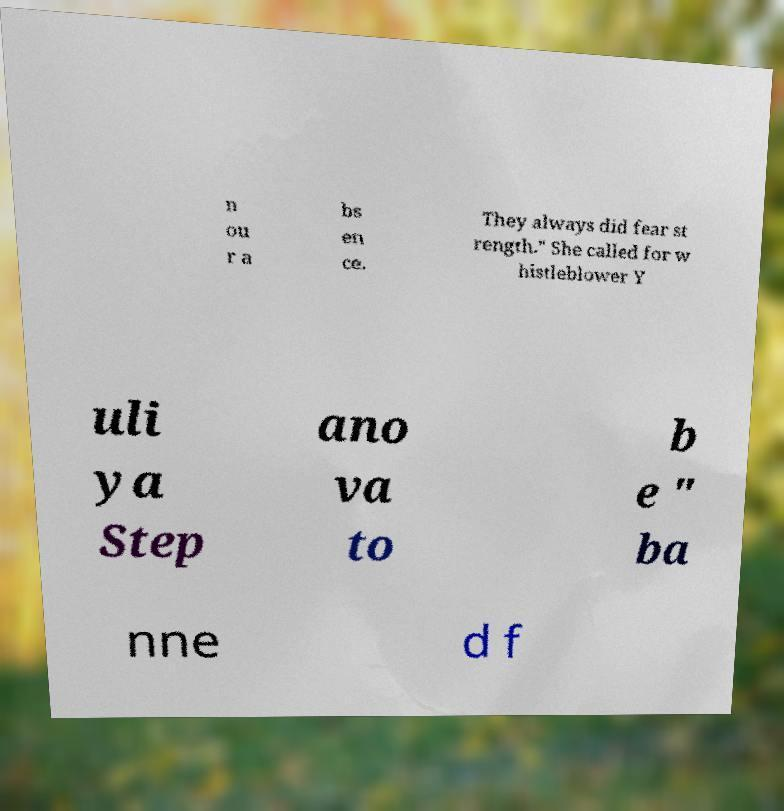Can you read and provide the text displayed in the image?This photo seems to have some interesting text. Can you extract and type it out for me? n ou r a bs en ce. They always did fear st rength." She called for w histleblower Y uli ya Step ano va to b e " ba nne d f 